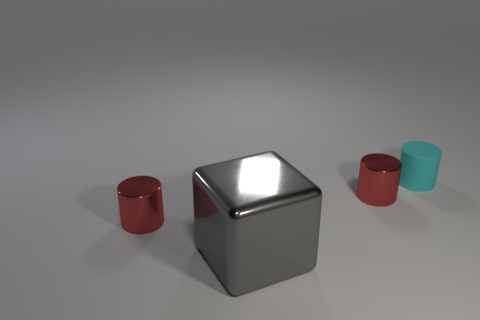How many things are either red things or cyan objects?
Keep it short and to the point. 3. What number of objects are both behind the large object and in front of the cyan rubber cylinder?
Give a very brief answer. 2. Is the number of gray objects left of the tiny matte cylinder less than the number of cyan rubber cylinders?
Keep it short and to the point. No. Is the gray cube the same size as the matte cylinder?
Offer a very short reply. No. How many things are either tiny red things or tiny cylinders that are in front of the cyan matte cylinder?
Your response must be concise. 2. Are there fewer cyan objects on the left side of the large gray thing than small cyan rubber objects that are behind the rubber cylinder?
Make the answer very short. No. What number of other things are there of the same material as the tiny cyan cylinder
Ensure brevity in your answer.  0. There is a small metallic object right of the large block; is it the same color as the large block?
Your response must be concise. No. Are there any tiny red metallic objects in front of the tiny red cylinder that is to the right of the gray shiny thing?
Ensure brevity in your answer.  Yes. There is a tiny cylinder that is right of the big gray object and in front of the small cyan matte thing; what material is it?
Give a very brief answer. Metal. 